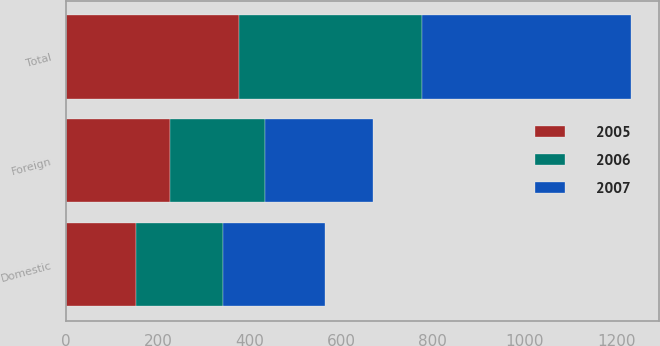Convert chart. <chart><loc_0><loc_0><loc_500><loc_500><stacked_bar_chart><ecel><fcel>Domestic<fcel>Foreign<fcel>Total<nl><fcel>2007<fcel>221.8<fcel>234.2<fcel>456<nl><fcel>2006<fcel>191.2<fcel>208.9<fcel>400.1<nl><fcel>2005<fcel>151.2<fcel>225.4<fcel>376.6<nl></chart> 